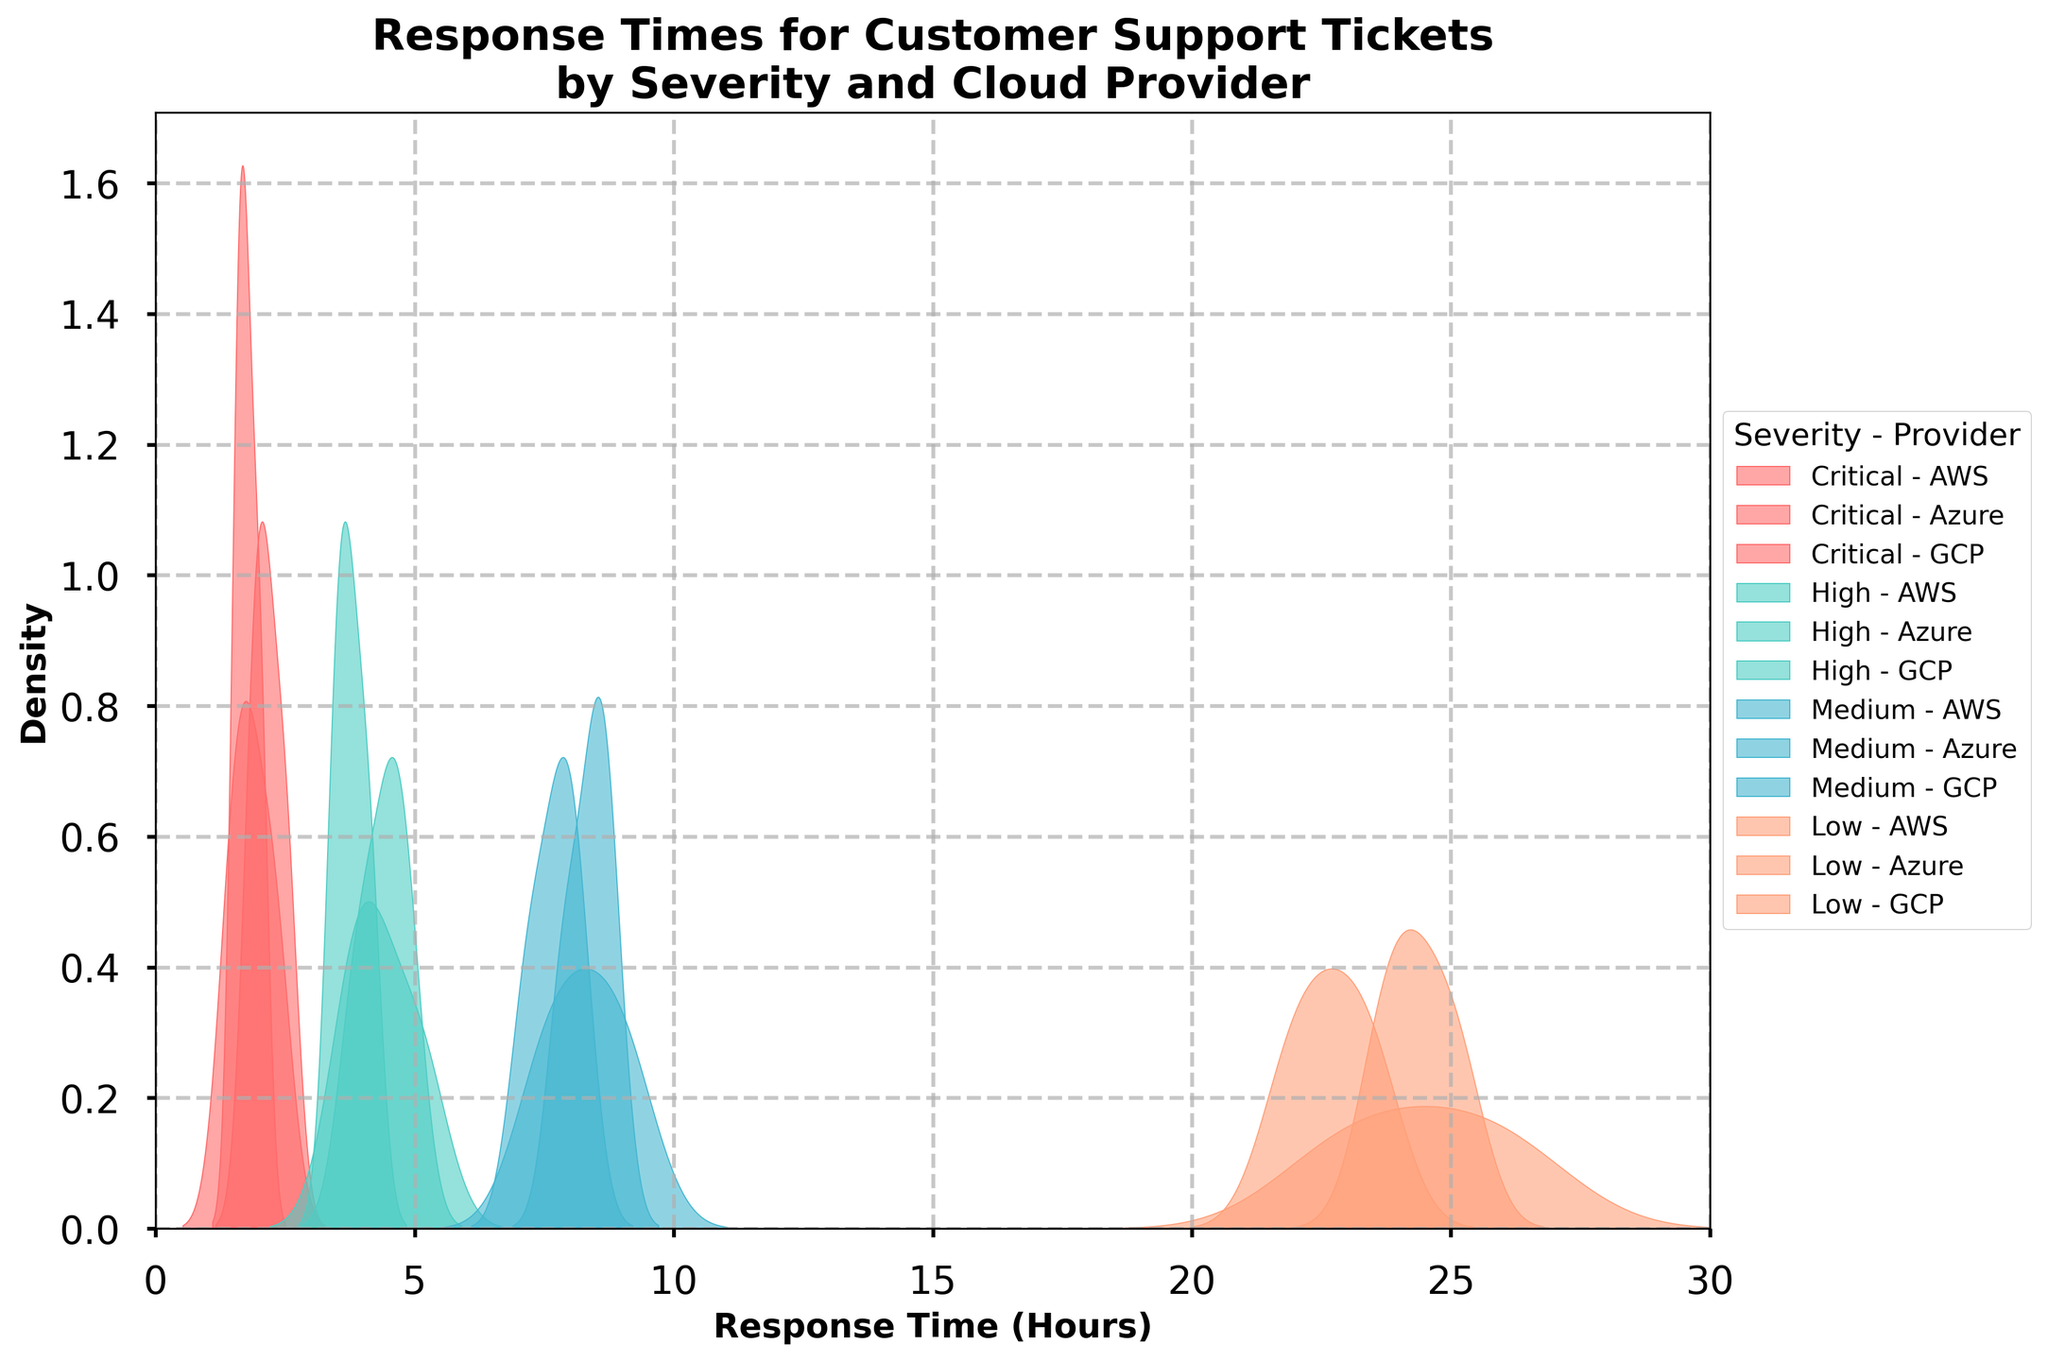What is the title of the figure? The title of the figure is the main text at the top that provides an overview of what the plot represents.
Answer: Response Times for Customer Support Tickets by Severity and Cloud Provider What is the range of the x-axis? The x-axis shows the range of response times in hours, indicated by the numerical labels. The range spans from 0 to 30 hours.
Answer: 0 to 30 Which severity category generally has the shortest response times? To determine which category has the shortest response times, look for the highest density peaks toward the left (shorter response time) side of the plot.
Answer: Critical Which provider has the longest response times for low severity issues? To find this, identify the peaks on the far right for each provider within the "Low" severity category. The furthest right peak will indicate the provider with the longest response times.
Answer: AWS Compare the spread of response times for high severity issues between AWS and GCP. Who is generally faster? To compare, look at where the density peaks are located relative to each other. The provider with peaks more to the left has generally faster response times.
Answer: GCP Which severity category shows the most variability in response times? Variability is indicated by the spread or width of the density peaks. The wider the peak, the higher the variability.
Answer: Low Are there any severity-response time trends observable from the figure? Observe the density plots for each severity level from left to right to identify any trends. Typically, higher severity issues should have lower response times, and this should decrease as severity lowers.
Answer: Higher severity issues tend to have shorter response times For critical issues, which provider has the lowest peak density value and what might this imply? Find the provider with the least prominent peaks (flattest density curve) within the "Critical" category. A lower peak density might imply more consistent response times without a single dominant response time range.
Answer: GCP What could be a plausible reason for AWS having the highest response times in the low severity category? Assuming AWS has higher peaks towards the right for low severity issues, factors could be prioritization, resource allocation, or service-level agreements (SLAs) favoring higher severity issues.
Answer: Resource prioritization How do Azure's response times for medium severity issues compare to AWS and GCP? Compare the density plots for Azure, AWS, and GCP within the medium category. Determine if Azure's peaks are more to the left or right.
Answer: Azure is generally slower than GCP but faster than AWS 